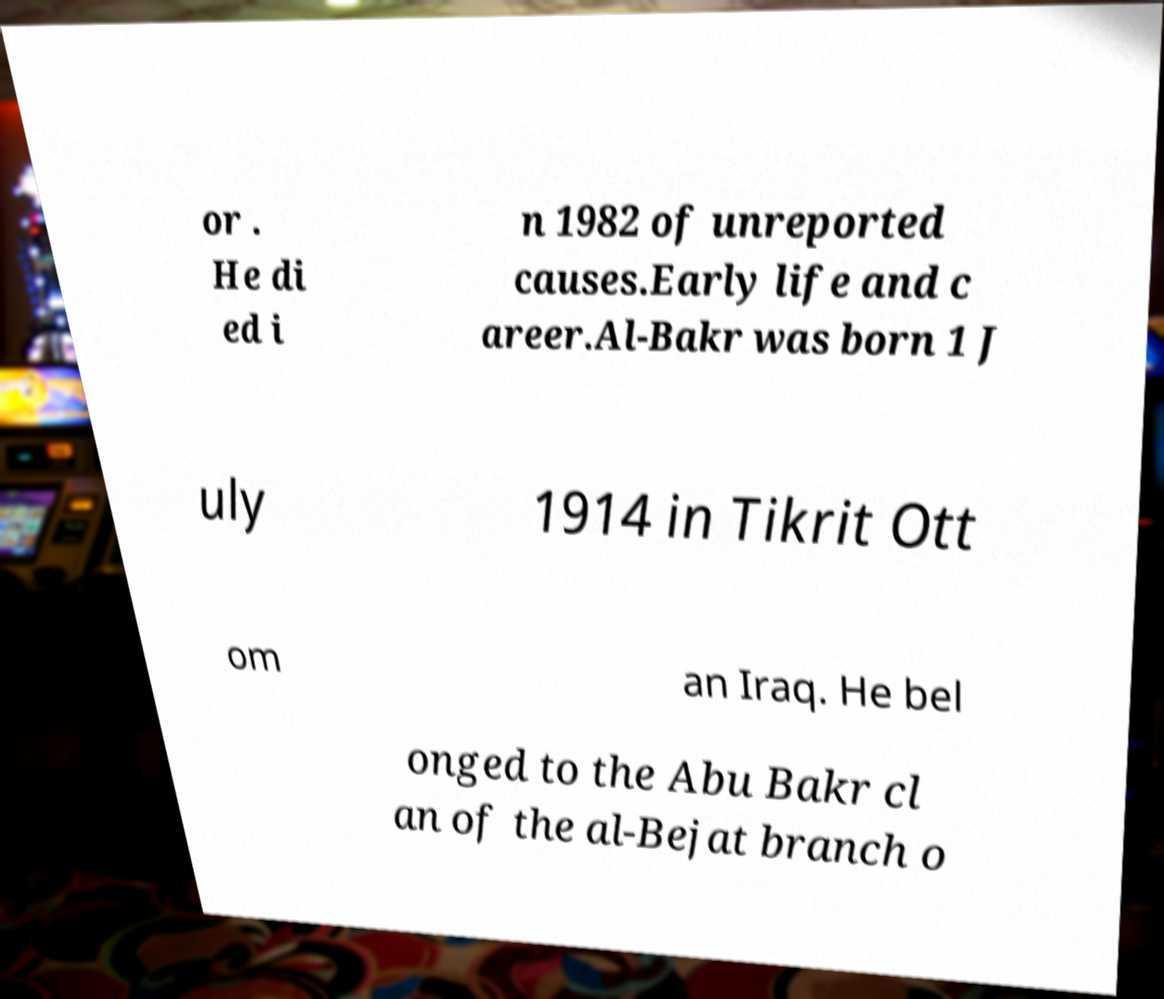Could you extract and type out the text from this image? or . He di ed i n 1982 of unreported causes.Early life and c areer.Al-Bakr was born 1 J uly 1914 in Tikrit Ott om an Iraq. He bel onged to the Abu Bakr cl an of the al-Bejat branch o 